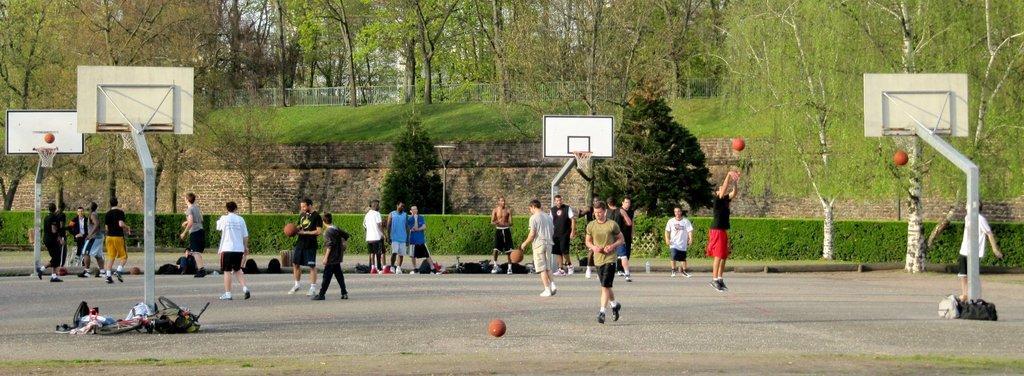Can you describe this image briefly? The picture consists of basketball courts and there are people playing basketball. On the court there are backpacks and balls. In the center of the picture there are trees, plants and wall. In the background there are trees, grass and fencing. 